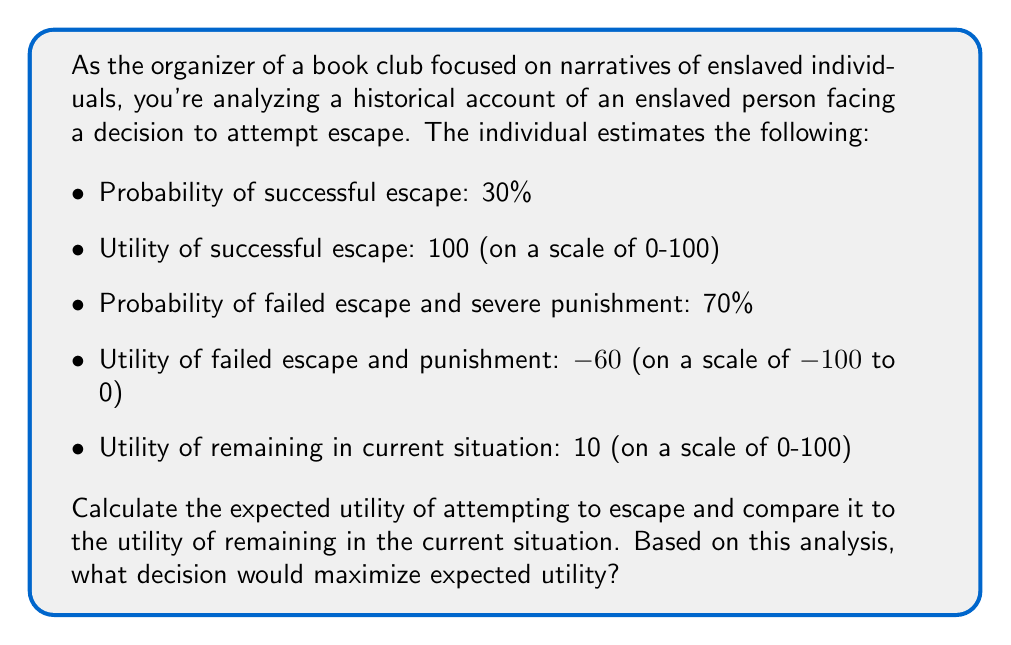Teach me how to tackle this problem. To solve this problem, we need to calculate the expected utility of attempting to escape and compare it to the utility of remaining in the current situation.

1. Calculate the expected utility of attempting to escape:

The expected utility is the sum of each possible outcome multiplied by its probability.

$$E(U_{escape}) = P(success) \times U(success) + P(failure) \times U(failure)$$

Where:
$E(U_{escape})$ = Expected utility of attempting escape
$P(success)$ = Probability of successful escape = 0.30
$U(success)$ = Utility of successful escape = 100
$P(failure)$ = Probability of failed escape = 0.70
$U(failure)$ = Utility of failed escape = -60

Plugging in the values:

$$E(U_{escape}) = 0.30 \times 100 + 0.70 \times (-60)$$
$$E(U_{escape}) = 30 - 42 = -12$$

2. Compare to the utility of remaining in the current situation:

The utility of remaining in the current situation is given as 10.

3. Decision analysis:

To maximize expected utility, we choose the option with the higher utility value.

$E(U_{escape}) = -12$ < $U(remain) = 10$

Since the expected utility of attempting to escape (-12) is less than the utility of remaining in the current situation (10), the decision that maximizes expected utility is to remain in the current situation.
Answer: The expected utility of attempting to escape is -12, which is less than the utility of remaining in the current situation (10). Therefore, based on this analysis, the decision that would maximize expected utility is to remain in the current situation. 